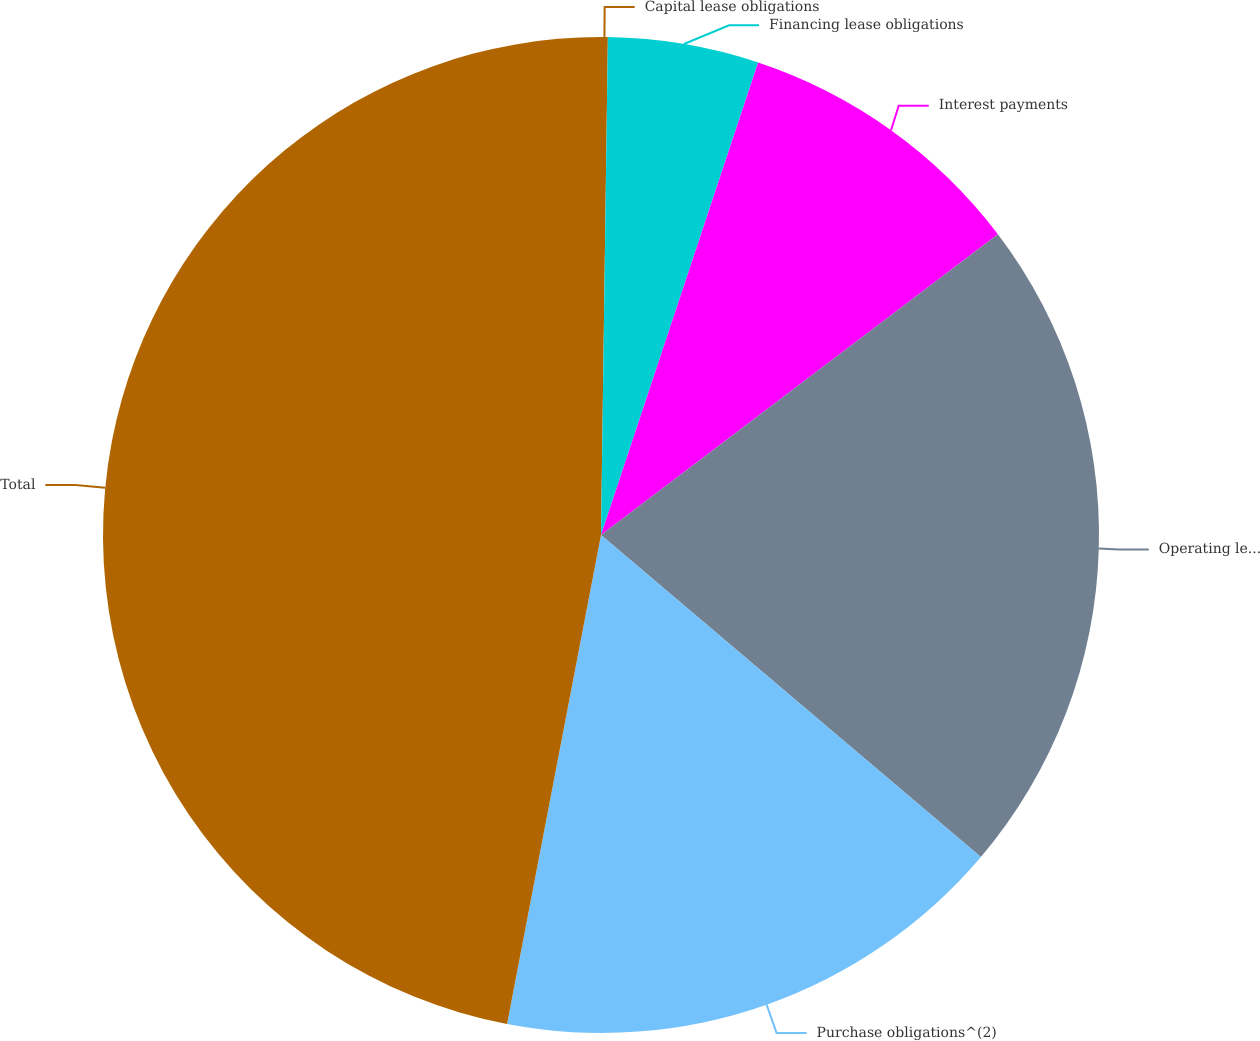Convert chart to OTSL. <chart><loc_0><loc_0><loc_500><loc_500><pie_chart><fcel>Capital lease obligations<fcel>Financing lease obligations<fcel>Interest payments<fcel>Operating lease<fcel>Purchase obligations^(2)<fcel>Total<nl><fcel>0.22%<fcel>4.89%<fcel>9.57%<fcel>21.51%<fcel>16.83%<fcel>46.98%<nl></chart> 